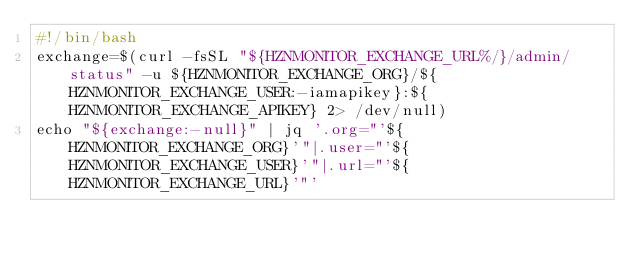Convert code to text. <code><loc_0><loc_0><loc_500><loc_500><_Bash_>#!/bin/bash
exchange=$(curl -fsSL "${HZNMONITOR_EXCHANGE_URL%/}/admin/status" -u ${HZNMONITOR_EXCHANGE_ORG}/${HZNMONITOR_EXCHANGE_USER:-iamapikey}:${HZNMONITOR_EXCHANGE_APIKEY} 2> /dev/null)
echo "${exchange:-null}" | jq '.org="'${HZNMONITOR_EXCHANGE_ORG}'"|.user="'${HZNMONITOR_EXCHANGE_USER}'"|.url="'${HZNMONITOR_EXCHANGE_URL}'"'

</code> 